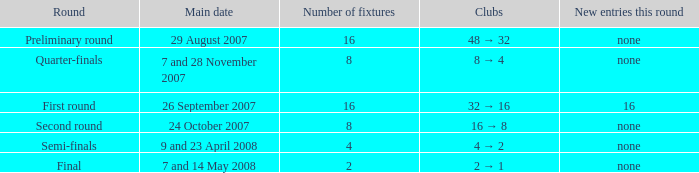What is the New entries this round when the round is the semi-finals? None. 